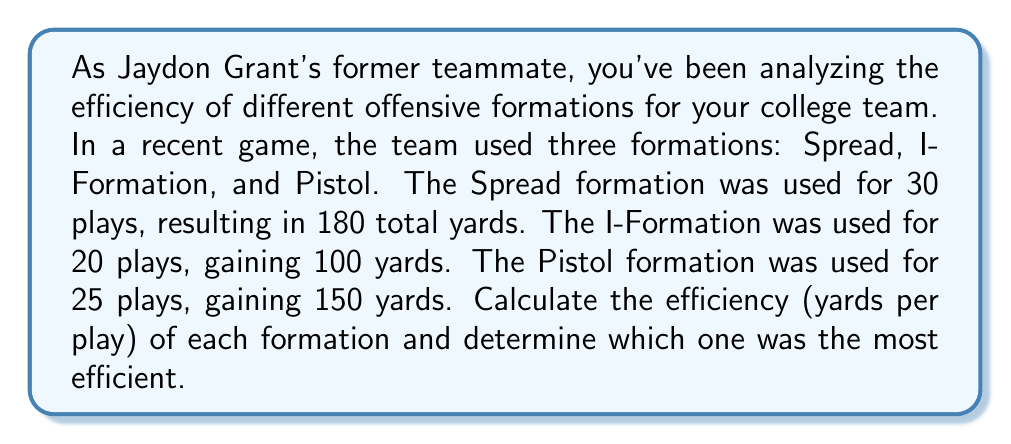Show me your answer to this math problem. To calculate the efficiency of each formation, we need to divide the total yards gained by the number of plays for each formation.

1. Spread Formation:
   $$ \text{Efficiency}_{\text{Spread}} = \frac{\text{Total Yards}}{\text{Number of Plays}} = \frac{180}{30} = 6 \text{ yards per play} $$

2. I-Formation:
   $$ \text{Efficiency}_{\text{I-Formation}} = \frac{\text{Total Yards}}{\text{Number of Plays}} = \frac{100}{20} = 5 \text{ yards per play} $$

3. Pistol Formation:
   $$ \text{Efficiency}_{\text{Pistol}} = \frac{\text{Total Yards}}{\text{Number of Plays}} = \frac{150}{25} = 6 \text{ yards per play} $$

To determine the most efficient formation, we compare the yards per play:

Spread: 6 yards/play
I-Formation: 5 yards/play
Pistol: 6 yards/play

The Spread and Pistol formations are equally efficient, both yielding 6 yards per play, which is higher than the I-Formation's 5 yards per play.
Answer: Spread: 6 yds/play, I-Formation: 5 yds/play, Pistol: 6 yds/play. Most efficient: Spread and Pistol (tie). 